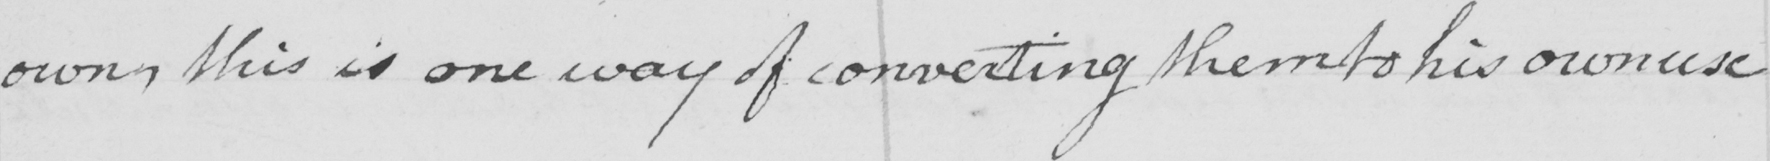Can you read and transcribe this handwriting? own this is one way of converting them to his own use 